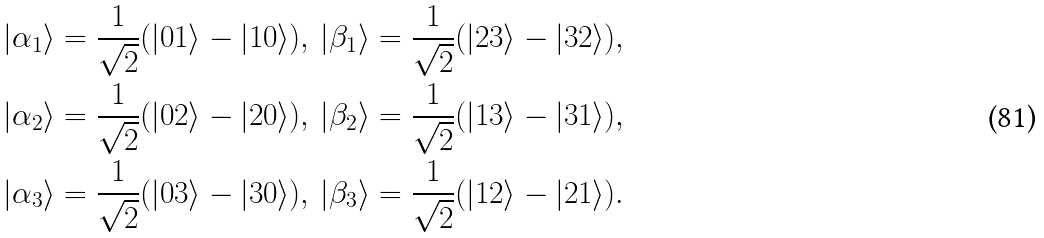<formula> <loc_0><loc_0><loc_500><loc_500>| \alpha _ { 1 } \rangle = \frac { 1 } { \sqrt { 2 } } ( | 0 1 \rangle - | 1 0 \rangle ) , \, | \beta _ { 1 } \rangle = \frac { 1 } { \sqrt { 2 } } ( | 2 3 \rangle - | 3 2 \rangle ) , \\ | \alpha _ { 2 } \rangle = \frac { 1 } { \sqrt { 2 } } ( | 0 2 \rangle - | 2 0 \rangle ) , \, | \beta _ { 2 } \rangle = \frac { 1 } { \sqrt { 2 } } ( | 1 3 \rangle - | 3 1 \rangle ) , \\ | \alpha _ { 3 } \rangle = \frac { 1 } { \sqrt { 2 } } ( | 0 3 \rangle - | 3 0 \rangle ) , \, | \beta _ { 3 } \rangle = \frac { 1 } { \sqrt { 2 } } ( | 1 2 \rangle - | 2 1 \rangle ) .</formula> 